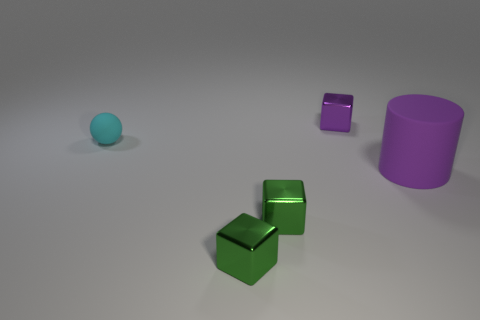Are there any large rubber cylinders to the right of the matte object right of the purple thing behind the big purple rubber object?
Make the answer very short. No. How many purple cylinders are left of the large purple cylinder?
Provide a succinct answer. 0. There is a tiny block that is the same color as the large cylinder; what is it made of?
Provide a short and direct response. Metal. How many large things are purple rubber cylinders or green metal cubes?
Provide a short and direct response. 1. There is a tiny object behind the tiny sphere; what shape is it?
Provide a succinct answer. Cube. Are there any small balls of the same color as the cylinder?
Ensure brevity in your answer.  No. Do the matte object that is on the left side of the big purple cylinder and the matte object to the right of the small cyan object have the same size?
Give a very brief answer. No. Are there more metallic objects to the right of the big purple rubber thing than purple blocks that are left of the cyan ball?
Keep it short and to the point. No. Is there a big purple thing made of the same material as the small purple cube?
Your answer should be compact. No. Is the rubber cylinder the same color as the ball?
Your response must be concise. No. 